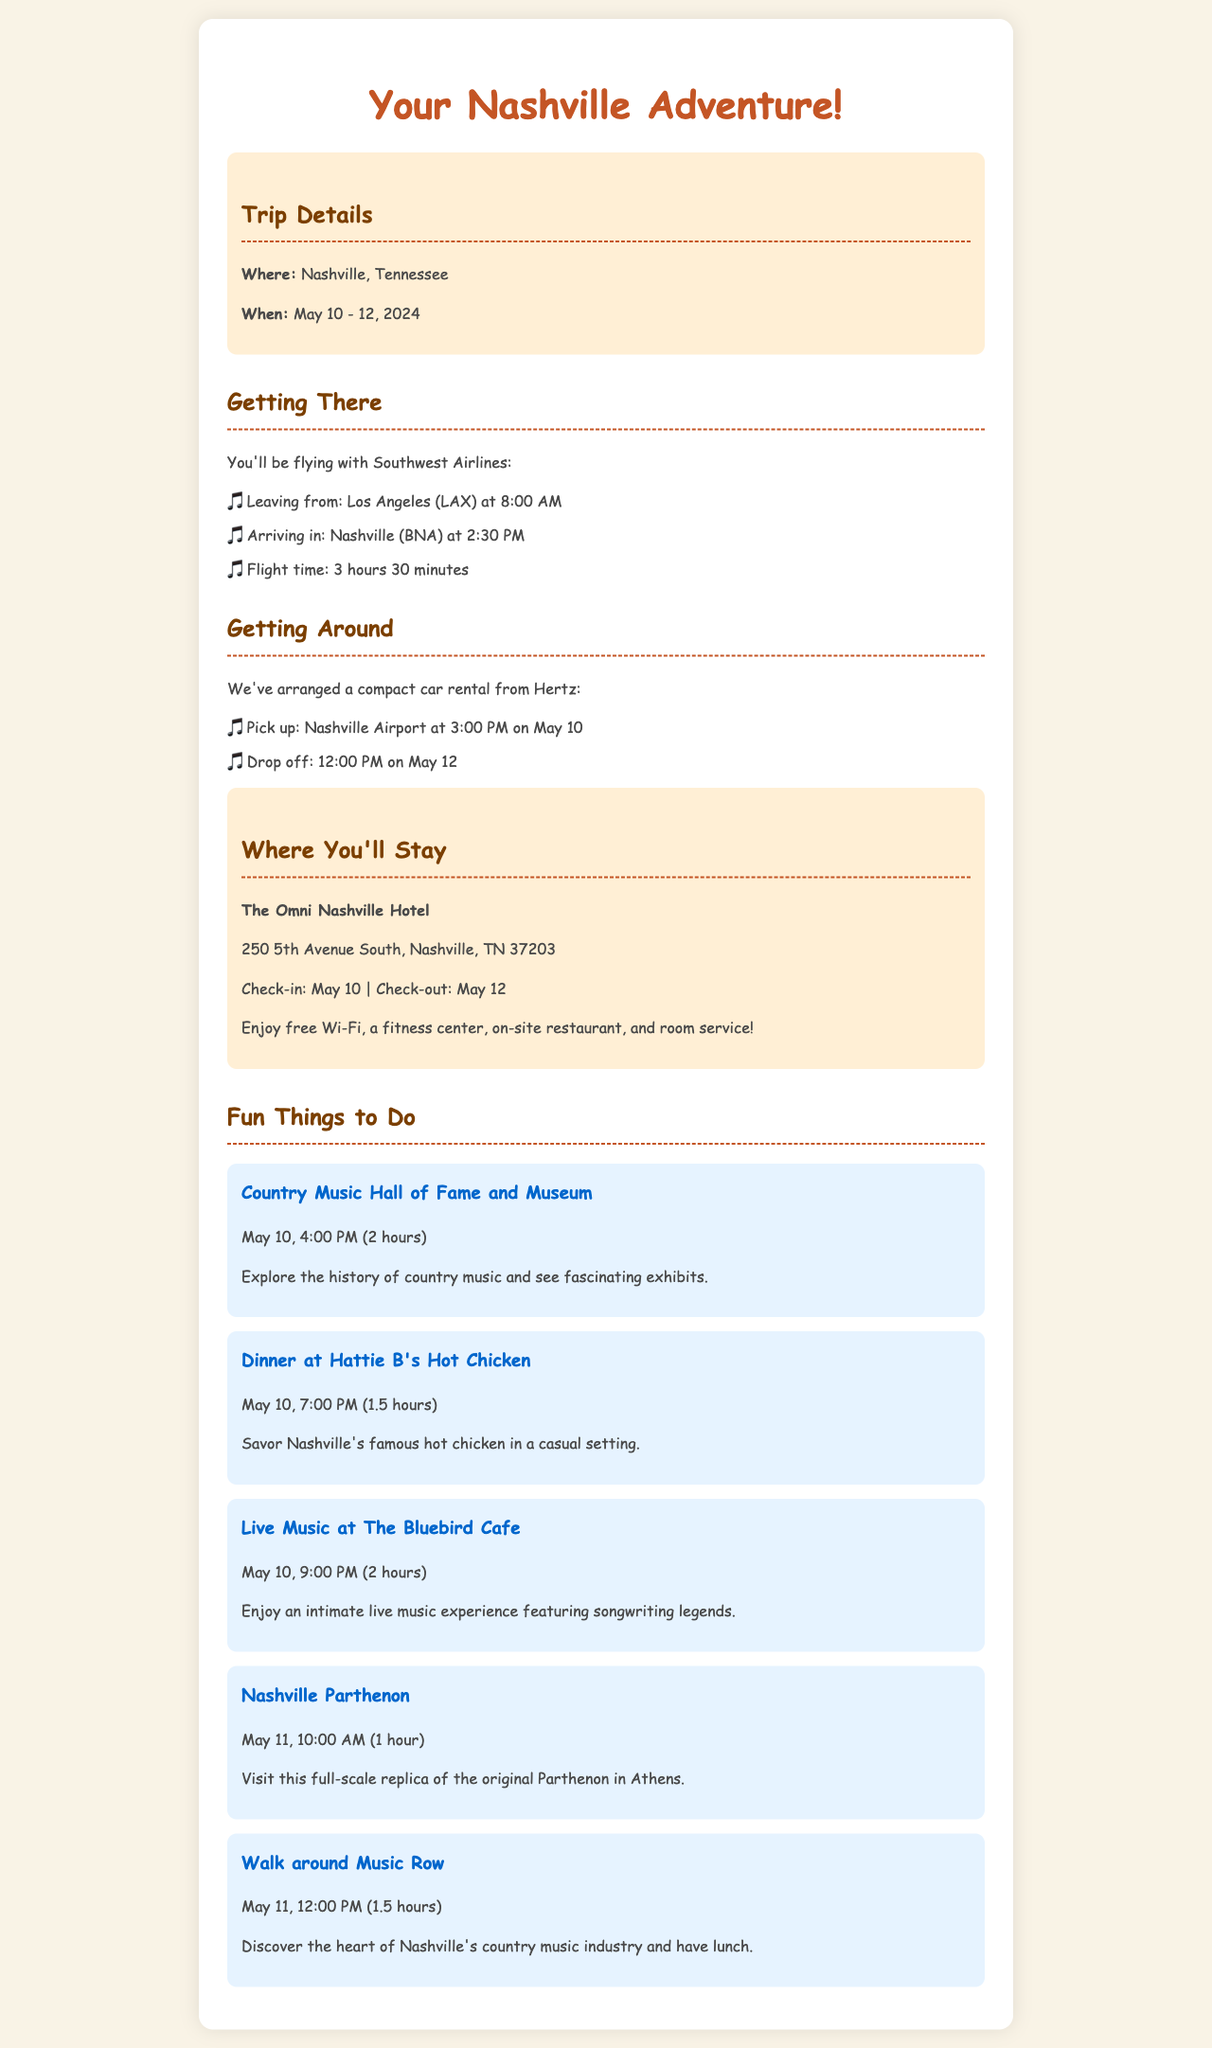what are the travel dates? The travel dates are specified in the document as May 10 - 12, 2024.
Answer: May 10 - 12, 2024 who is the airline provider? The document states that the airline you'll be flying with is Southwest Airlines.
Answer: Southwest Airlines what time does the flight leave? The document indicates the flight leaves Los Angeles at 8:00 AM.
Answer: 8:00 AM what is the return time for the car rental? The return time for the car rental is mentioned as 12:00 PM on May 12.
Answer: 12:00 PM on May 12 how long is the visit to the Country Music Hall of Fame? The visit is scheduled for 2 hours from 4:00 PM to 6:00 PM on May 10.
Answer: 2 hours which hotel are you staying at? The hotel listed for the stay is The Omni Nashville Hotel.
Answer: The Omni Nashville Hotel what activity occurs after dinner on the first day? The activity scheduled after dinner is live music at The Bluebird Cafe.
Answer: Live music at The Bluebird Cafe how many activities are suggested for May 10? There are three activities suggested for May 10.
Answer: Three activities what time is check-in at the hotel? The check-in time at the hotel is stated as May 10.
Answer: May 10 